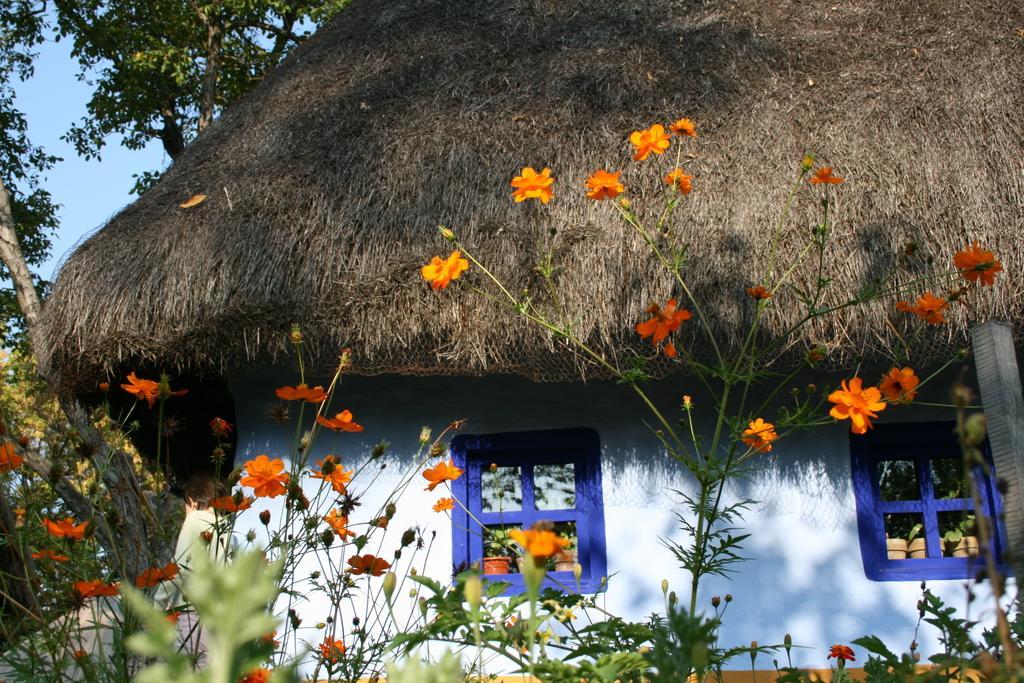Could you give a brief overview of what you see in this image? In this picture we can see the white color small house with straw roof. In the front bottom side we can see orange color flower plant. 